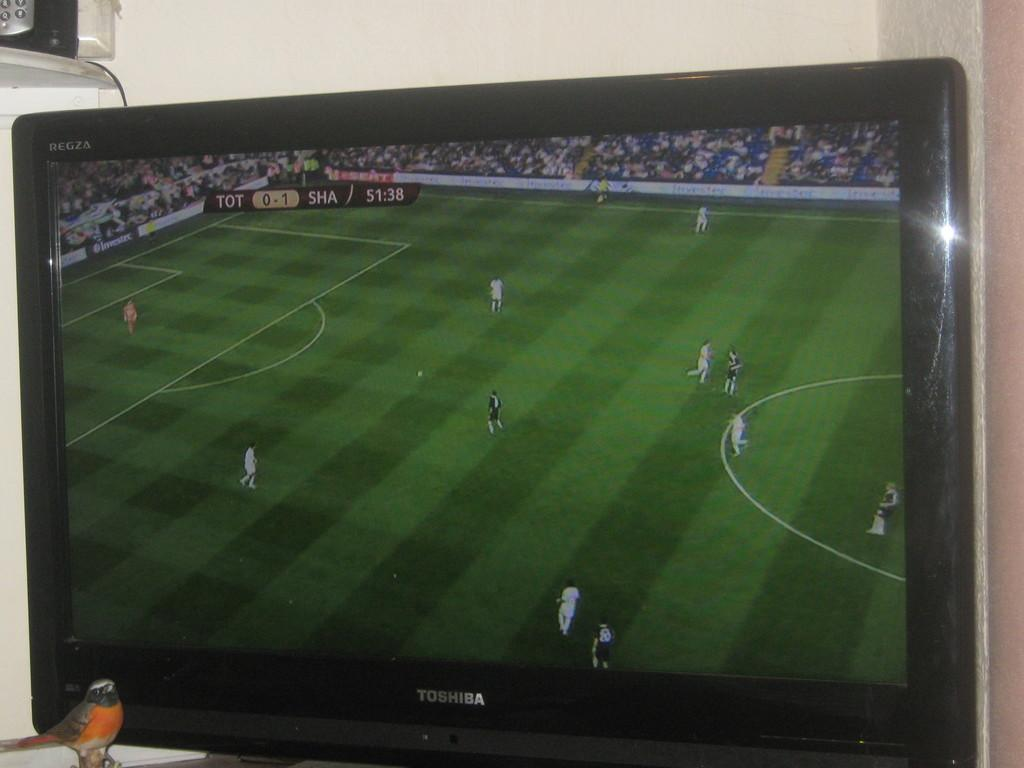<image>
Present a compact description of the photo's key features. a television shows the image of soccer players on a Toshiba 